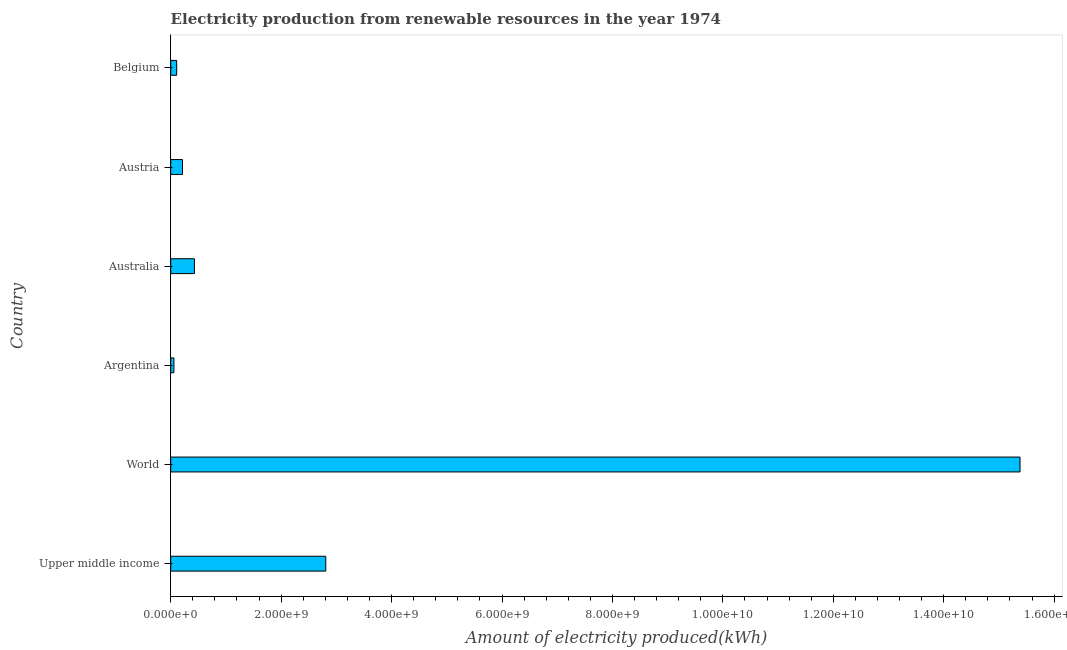What is the title of the graph?
Your answer should be very brief. Electricity production from renewable resources in the year 1974. What is the label or title of the X-axis?
Provide a succinct answer. Amount of electricity produced(kWh). What is the amount of electricity produced in Argentina?
Your answer should be very brief. 5.80e+07. Across all countries, what is the maximum amount of electricity produced?
Ensure brevity in your answer.  1.54e+1. Across all countries, what is the minimum amount of electricity produced?
Provide a short and direct response. 5.80e+07. In which country was the amount of electricity produced maximum?
Your response must be concise. World. In which country was the amount of electricity produced minimum?
Your answer should be very brief. Argentina. What is the sum of the amount of electricity produced?
Ensure brevity in your answer.  1.90e+1. What is the difference between the amount of electricity produced in Australia and Austria?
Keep it short and to the point. 2.16e+08. What is the average amount of electricity produced per country?
Ensure brevity in your answer.  3.17e+09. What is the median amount of electricity produced?
Your answer should be very brief. 3.21e+08. What is the ratio of the amount of electricity produced in Argentina to that in Belgium?
Your answer should be compact. 0.54. What is the difference between the highest and the second highest amount of electricity produced?
Your answer should be compact. 1.26e+1. Is the sum of the amount of electricity produced in Belgium and World greater than the maximum amount of electricity produced across all countries?
Provide a short and direct response. Yes. What is the difference between the highest and the lowest amount of electricity produced?
Give a very brief answer. 1.53e+1. Are all the bars in the graph horizontal?
Keep it short and to the point. Yes. How many countries are there in the graph?
Make the answer very short. 6. What is the difference between two consecutive major ticks on the X-axis?
Ensure brevity in your answer.  2.00e+09. Are the values on the major ticks of X-axis written in scientific E-notation?
Offer a very short reply. Yes. What is the Amount of electricity produced(kWh) of Upper middle income?
Keep it short and to the point. 2.81e+09. What is the Amount of electricity produced(kWh) in World?
Provide a succinct answer. 1.54e+1. What is the Amount of electricity produced(kWh) in Argentina?
Ensure brevity in your answer.  5.80e+07. What is the Amount of electricity produced(kWh) of Australia?
Your answer should be compact. 4.29e+08. What is the Amount of electricity produced(kWh) of Austria?
Ensure brevity in your answer.  2.13e+08. What is the Amount of electricity produced(kWh) of Belgium?
Your response must be concise. 1.08e+08. What is the difference between the Amount of electricity produced(kWh) in Upper middle income and World?
Give a very brief answer. -1.26e+1. What is the difference between the Amount of electricity produced(kWh) in Upper middle income and Argentina?
Provide a short and direct response. 2.75e+09. What is the difference between the Amount of electricity produced(kWh) in Upper middle income and Australia?
Give a very brief answer. 2.38e+09. What is the difference between the Amount of electricity produced(kWh) in Upper middle income and Austria?
Offer a terse response. 2.60e+09. What is the difference between the Amount of electricity produced(kWh) in Upper middle income and Belgium?
Give a very brief answer. 2.70e+09. What is the difference between the Amount of electricity produced(kWh) in World and Argentina?
Provide a succinct answer. 1.53e+1. What is the difference between the Amount of electricity produced(kWh) in World and Australia?
Make the answer very short. 1.50e+1. What is the difference between the Amount of electricity produced(kWh) in World and Austria?
Your answer should be very brief. 1.52e+1. What is the difference between the Amount of electricity produced(kWh) in World and Belgium?
Give a very brief answer. 1.53e+1. What is the difference between the Amount of electricity produced(kWh) in Argentina and Australia?
Offer a terse response. -3.71e+08. What is the difference between the Amount of electricity produced(kWh) in Argentina and Austria?
Your response must be concise. -1.55e+08. What is the difference between the Amount of electricity produced(kWh) in Argentina and Belgium?
Offer a terse response. -5.00e+07. What is the difference between the Amount of electricity produced(kWh) in Australia and Austria?
Give a very brief answer. 2.16e+08. What is the difference between the Amount of electricity produced(kWh) in Australia and Belgium?
Your answer should be compact. 3.21e+08. What is the difference between the Amount of electricity produced(kWh) in Austria and Belgium?
Offer a very short reply. 1.05e+08. What is the ratio of the Amount of electricity produced(kWh) in Upper middle income to that in World?
Offer a terse response. 0.18. What is the ratio of the Amount of electricity produced(kWh) in Upper middle income to that in Argentina?
Your answer should be very brief. 48.41. What is the ratio of the Amount of electricity produced(kWh) in Upper middle income to that in Australia?
Keep it short and to the point. 6.54. What is the ratio of the Amount of electricity produced(kWh) in Upper middle income to that in Austria?
Provide a succinct answer. 13.18. What is the ratio of the Amount of electricity produced(kWh) in Upper middle income to that in Belgium?
Your answer should be compact. 26. What is the ratio of the Amount of electricity produced(kWh) in World to that in Argentina?
Ensure brevity in your answer.  265.21. What is the ratio of the Amount of electricity produced(kWh) in World to that in Australia?
Provide a short and direct response. 35.85. What is the ratio of the Amount of electricity produced(kWh) in World to that in Austria?
Make the answer very short. 72.22. What is the ratio of the Amount of electricity produced(kWh) in World to that in Belgium?
Your answer should be very brief. 142.43. What is the ratio of the Amount of electricity produced(kWh) in Argentina to that in Australia?
Offer a very short reply. 0.14. What is the ratio of the Amount of electricity produced(kWh) in Argentina to that in Austria?
Make the answer very short. 0.27. What is the ratio of the Amount of electricity produced(kWh) in Argentina to that in Belgium?
Make the answer very short. 0.54. What is the ratio of the Amount of electricity produced(kWh) in Australia to that in Austria?
Make the answer very short. 2.01. What is the ratio of the Amount of electricity produced(kWh) in Australia to that in Belgium?
Your response must be concise. 3.97. What is the ratio of the Amount of electricity produced(kWh) in Austria to that in Belgium?
Offer a terse response. 1.97. 